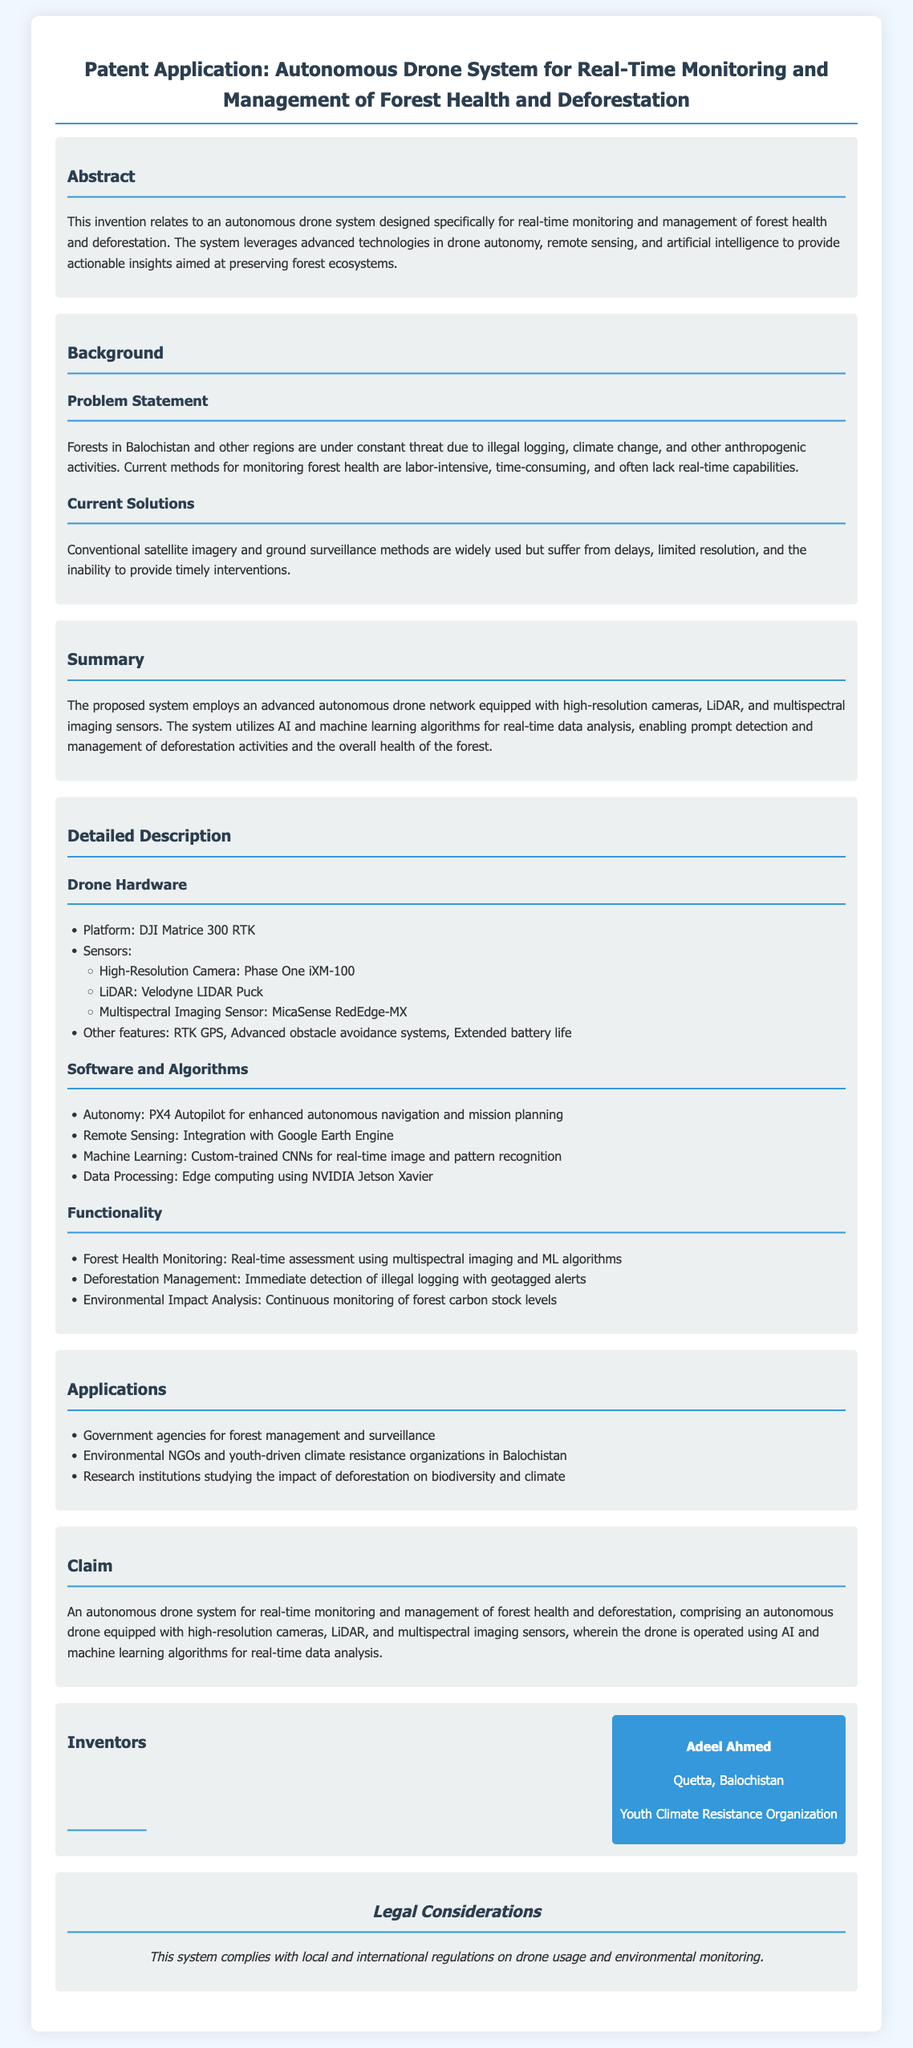What is the name of the proposed system? The document states that the proposed system is an "autonomous drone system designed specifically for real-time monitoring and management of forest health and deforestation."
Answer: autonomous drone system Who is the inventor of the drone system? The document provides the name of the inventor as "Adeel Ahmed."
Answer: Adeel Ahmed What is one of the sensors used in the drone? The document lists several sensors, including a "High-Resolution Camera: Phase One iXM-100."
Answer: Phase One iXM-100 What type of algorithms does the system use for data analysis? The document mentions the use of "AI and machine learning algorithms for real-time data analysis."
Answer: AI and machine learning What is the primary purpose of the drone system? The document highlights that the main purpose is "providing actionable insights aimed at preserving forest ecosystems."
Answer: preserving forest ecosystems Which platform is the drone based on? The document specifies that the drone platform is "DJI Matrice 300 RTK."
Answer: DJI Matrice 300 RTK What is a key feature of the drone's hardware? The document describes "Advanced obstacle avoidance systems" as a key feature of the drone's hardware.
Answer: Advanced obstacle avoidance systems Which sector can benefit from this drone system? The document lists "Environmental NGOs and youth-driven climate resistance organizations in Balochistan" as potential beneficiaries.
Answer: Environmental NGOs and youth-driven climate resistance organizations in Balochistan What legal consideration is mentioned in the application? The document states that "This system complies with local and international regulations on drone usage and environmental monitoring."
Answer: compliance with regulations 